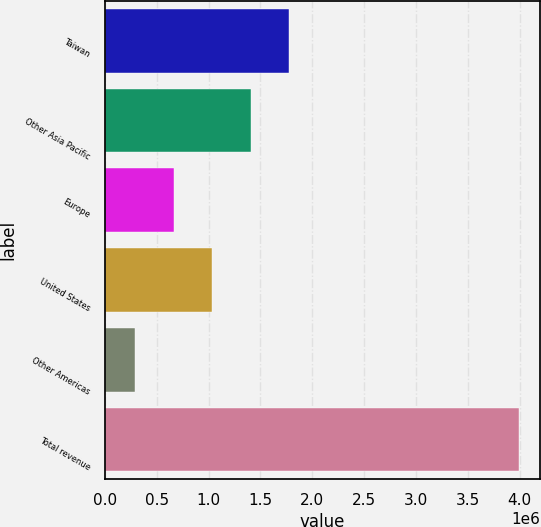Convert chart. <chart><loc_0><loc_0><loc_500><loc_500><bar_chart><fcel>Taiwan<fcel>Other Asia Pacific<fcel>Europe<fcel>United States<fcel>Other Americas<fcel>Total revenue<nl><fcel>1.77624e+06<fcel>1.40596e+06<fcel>665396<fcel>1.03568e+06<fcel>295114<fcel>3.99793e+06<nl></chart> 